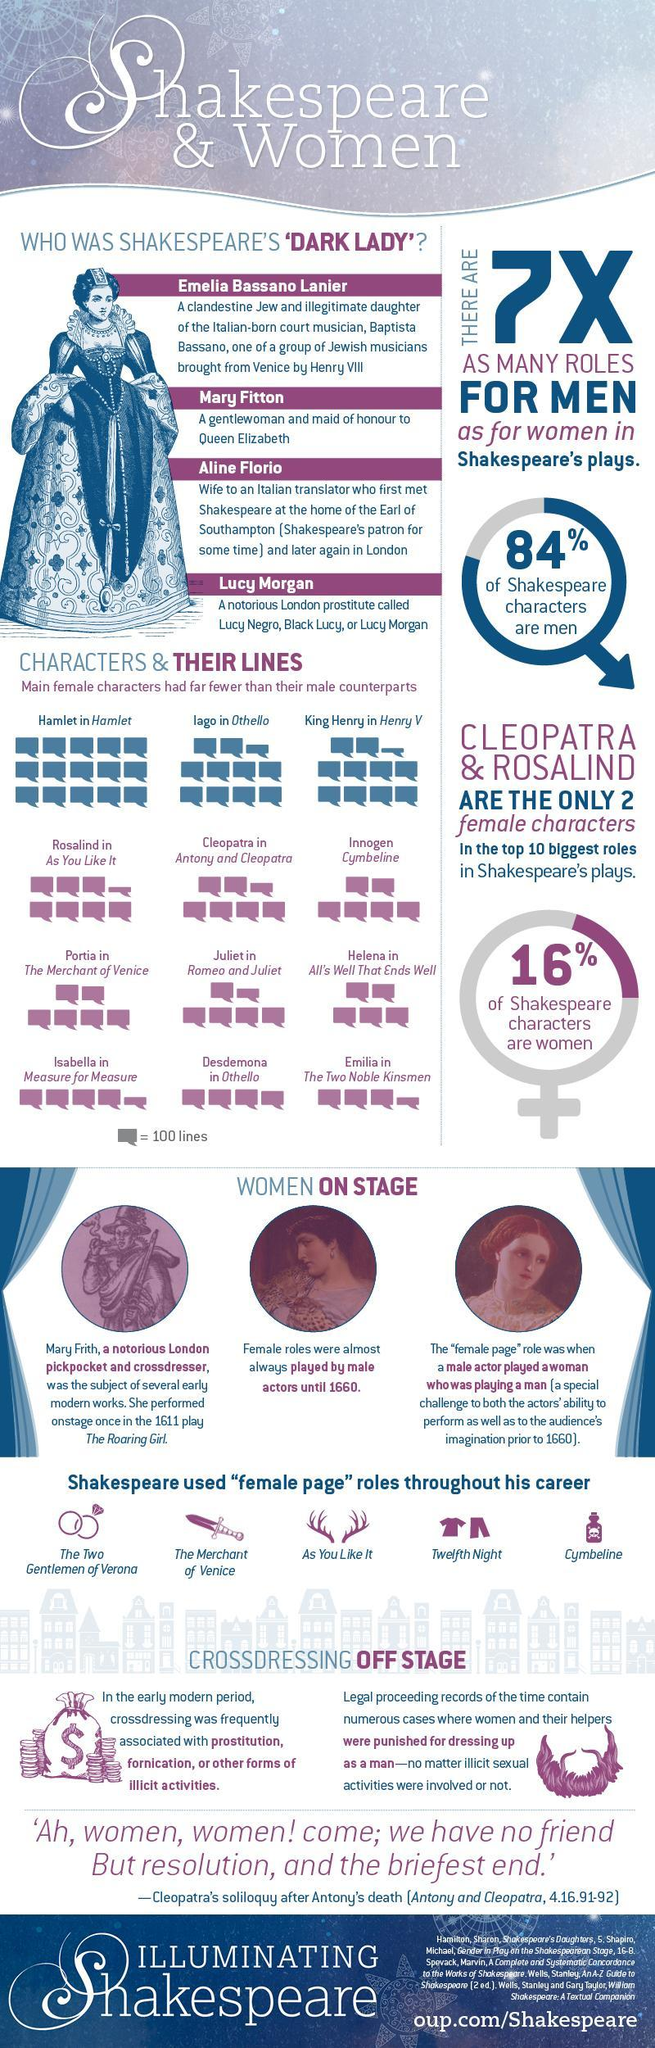What were the number of lines Rosalind had in "As you like it" ?
Answer the question with a short phrase. 725 Which woman character in Shakespeare's play had the least number of lines? Emilia Which Shakespearean novel has the female character saying about 400 lines? Othello What were the number of lines Cleopatra had in "Antony and Cleopatra" ? 650 